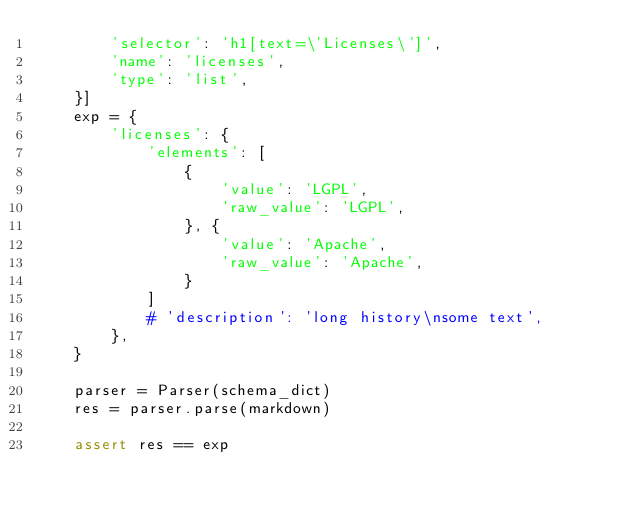Convert code to text. <code><loc_0><loc_0><loc_500><loc_500><_Python_>        'selector': 'h1[text=\'Licenses\']',
        'name': 'licenses',
        'type': 'list',
    }]
    exp = {
        'licenses': {
            'elements': [
                {
                    'value': 'LGPL',
                    'raw_value': 'LGPL',
                }, {
                    'value': 'Apache',
                    'raw_value': 'Apache',
                }
            ]
            # 'description': 'long history\nsome text',
        },
    }

    parser = Parser(schema_dict)
    res = parser.parse(markdown)

    assert res == exp
</code> 